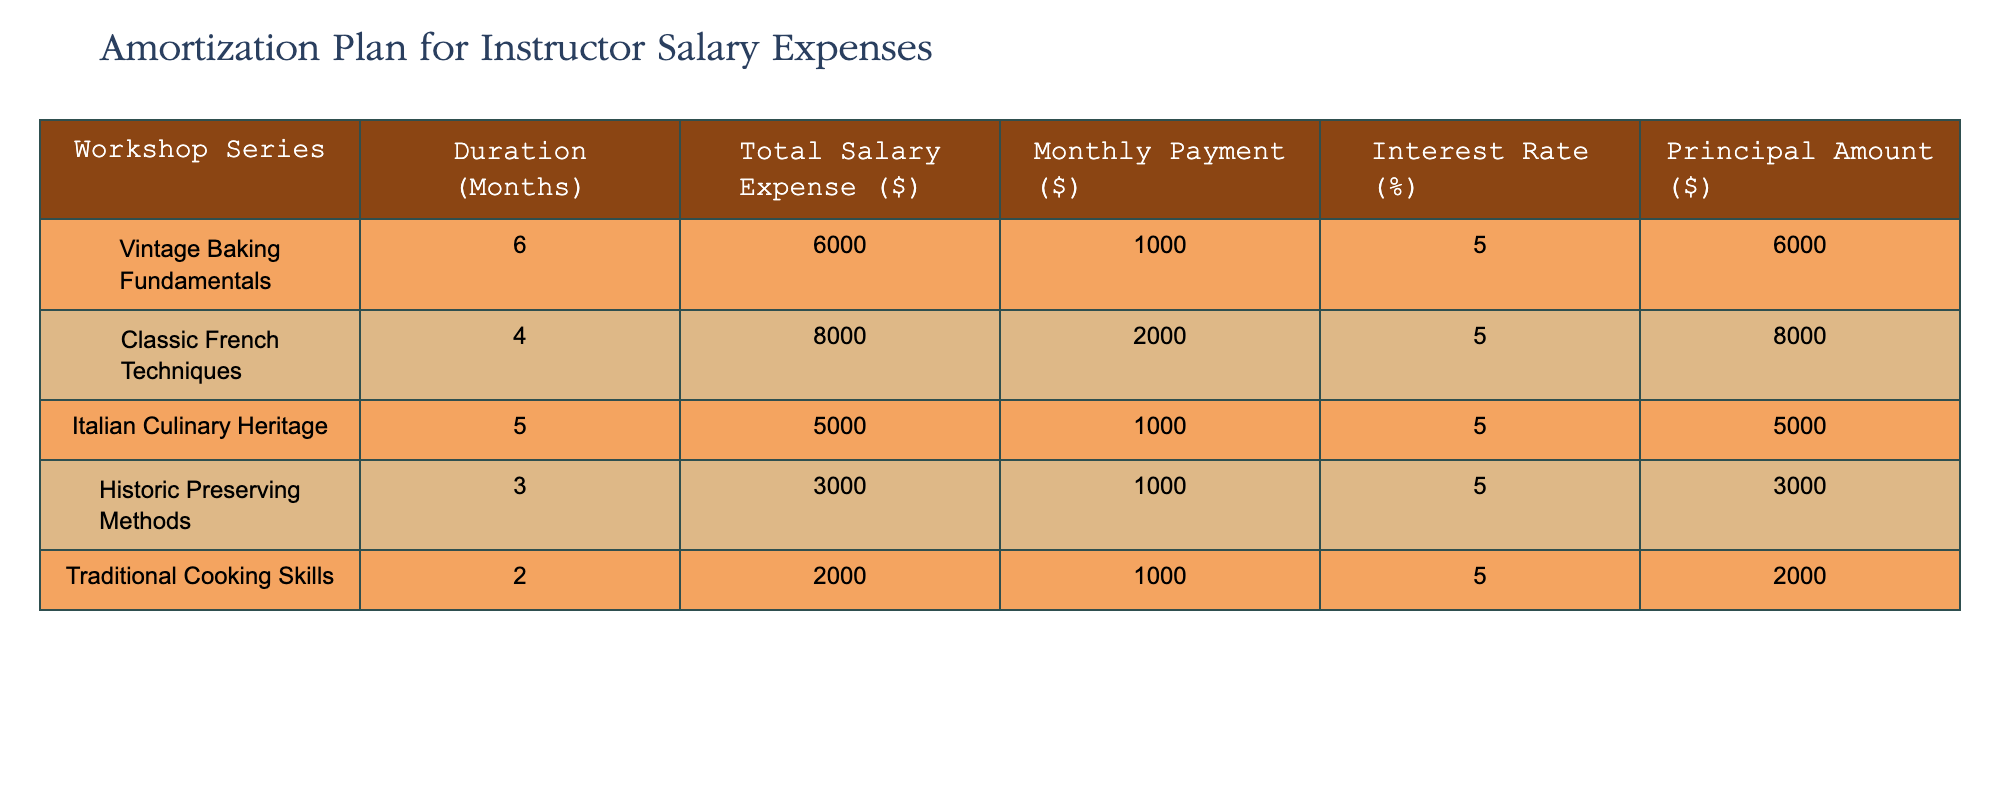What is the total salary expense for the Vintage Baking Fundamentals workshop? Referring to the table, the total salary expense for the Vintage Baking Fundamentals workshop is located in the "Total Salary Expense ($)" column for that specific row. The value is 6000.
Answer: 6000 How long is the duration of the Traditional Cooking Skills workshop? The duration of the Traditional Cooking Skills workshop can be found in the "Duration (Months)" column corresponding to that workshop. The value is 2 months.
Answer: 2 months Is the monthly payment for the Classic French Techniques workshop greater than 1500? By looking at the "Monthly Payment ($)" column for the Classic French Techniques workshop, the value is 2000. Since 2000 is greater than 1500, the answer is yes.
Answer: Yes What is the average total salary expense across all workshops? To find the average total salary expense, sum the totals from the "Total Salary Expense ($)" column: 6000 + 8000 + 5000 + 3000 + 2000 = 24000. Then divide by the number of workshops (5): 24000 / 5 = 4800.
Answer: 4800 Which workshop has the highest monthly payment, and what is that amount? By comparing the values in the "Monthly Payment ($)" column, Classic French Techniques has the highest value at 2000.
Answer: Classic French Techniques, 2000 What is the total salary expense for workshops lasting more than 4 months? To find the total salary expense for workshops longer than 4 months, look at the workshops with durations of 6 (Vintage Baking Fundamentals) and 5 (Italian Culinary Heritage) months. The expenses are 6000 and 5000, respectively. Adding them gives 6000 + 5000 = 11000.
Answer: 11000 Is the total salary expense for Historic Preserving Methods less than 4000? Checking the "Total Salary Expense ($)" for Historic Preserving Methods shows a value of 3000, which is indeed less than 4000, making the statement true.
Answer: Yes What is the difference in total salary expenses between the workshop with the highest and lowest expenses? The highest expense is 8000 for Classic French Techniques, and the lowest is 2000 for Traditional Cooking Skills. The difference is 8000 - 2000 = 6000.
Answer: 6000 What percentage of the total salary expense does the Italian Culinary Heritage workshop represent? The total salary expenses for all workshops sum up to 24000. Italian Culinary Heritage has an expense of 5000. To find the percentage, calculate (5000 / 24000) * 100, which gives approximately 20.83%.
Answer: 20.83% 